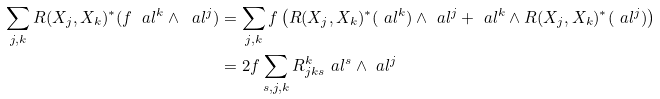<formula> <loc_0><loc_0><loc_500><loc_500>\sum _ { j , k } R ( X _ { j } , X _ { k } ) ^ { * } ( f \ a l ^ { k } \wedge \ a l ^ { j } ) & = \sum _ { j , k } f \left ( R ( X _ { j } , X _ { k } ) ^ { * } ( \ a l ^ { k } ) \wedge \ a l ^ { j } + \ a l ^ { k } \wedge R ( X _ { j } , X _ { k } ) ^ { * } ( \ a l ^ { j } ) \right ) \\ & = 2 f \sum _ { s , j , k } R ^ { k } _ { j k s } \ a l ^ { s } \wedge \ a l ^ { j }</formula> 